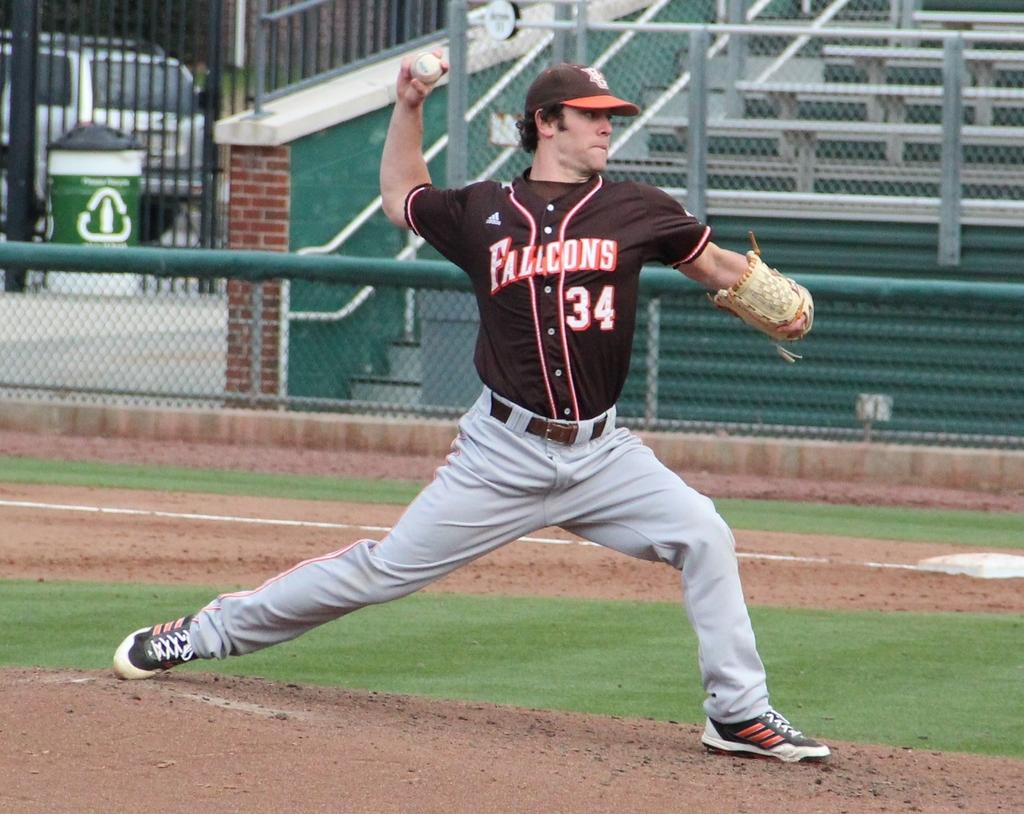<image>
Give a short and clear explanation of the subsequent image. Player number 34 for the Flacons throws a pitch 